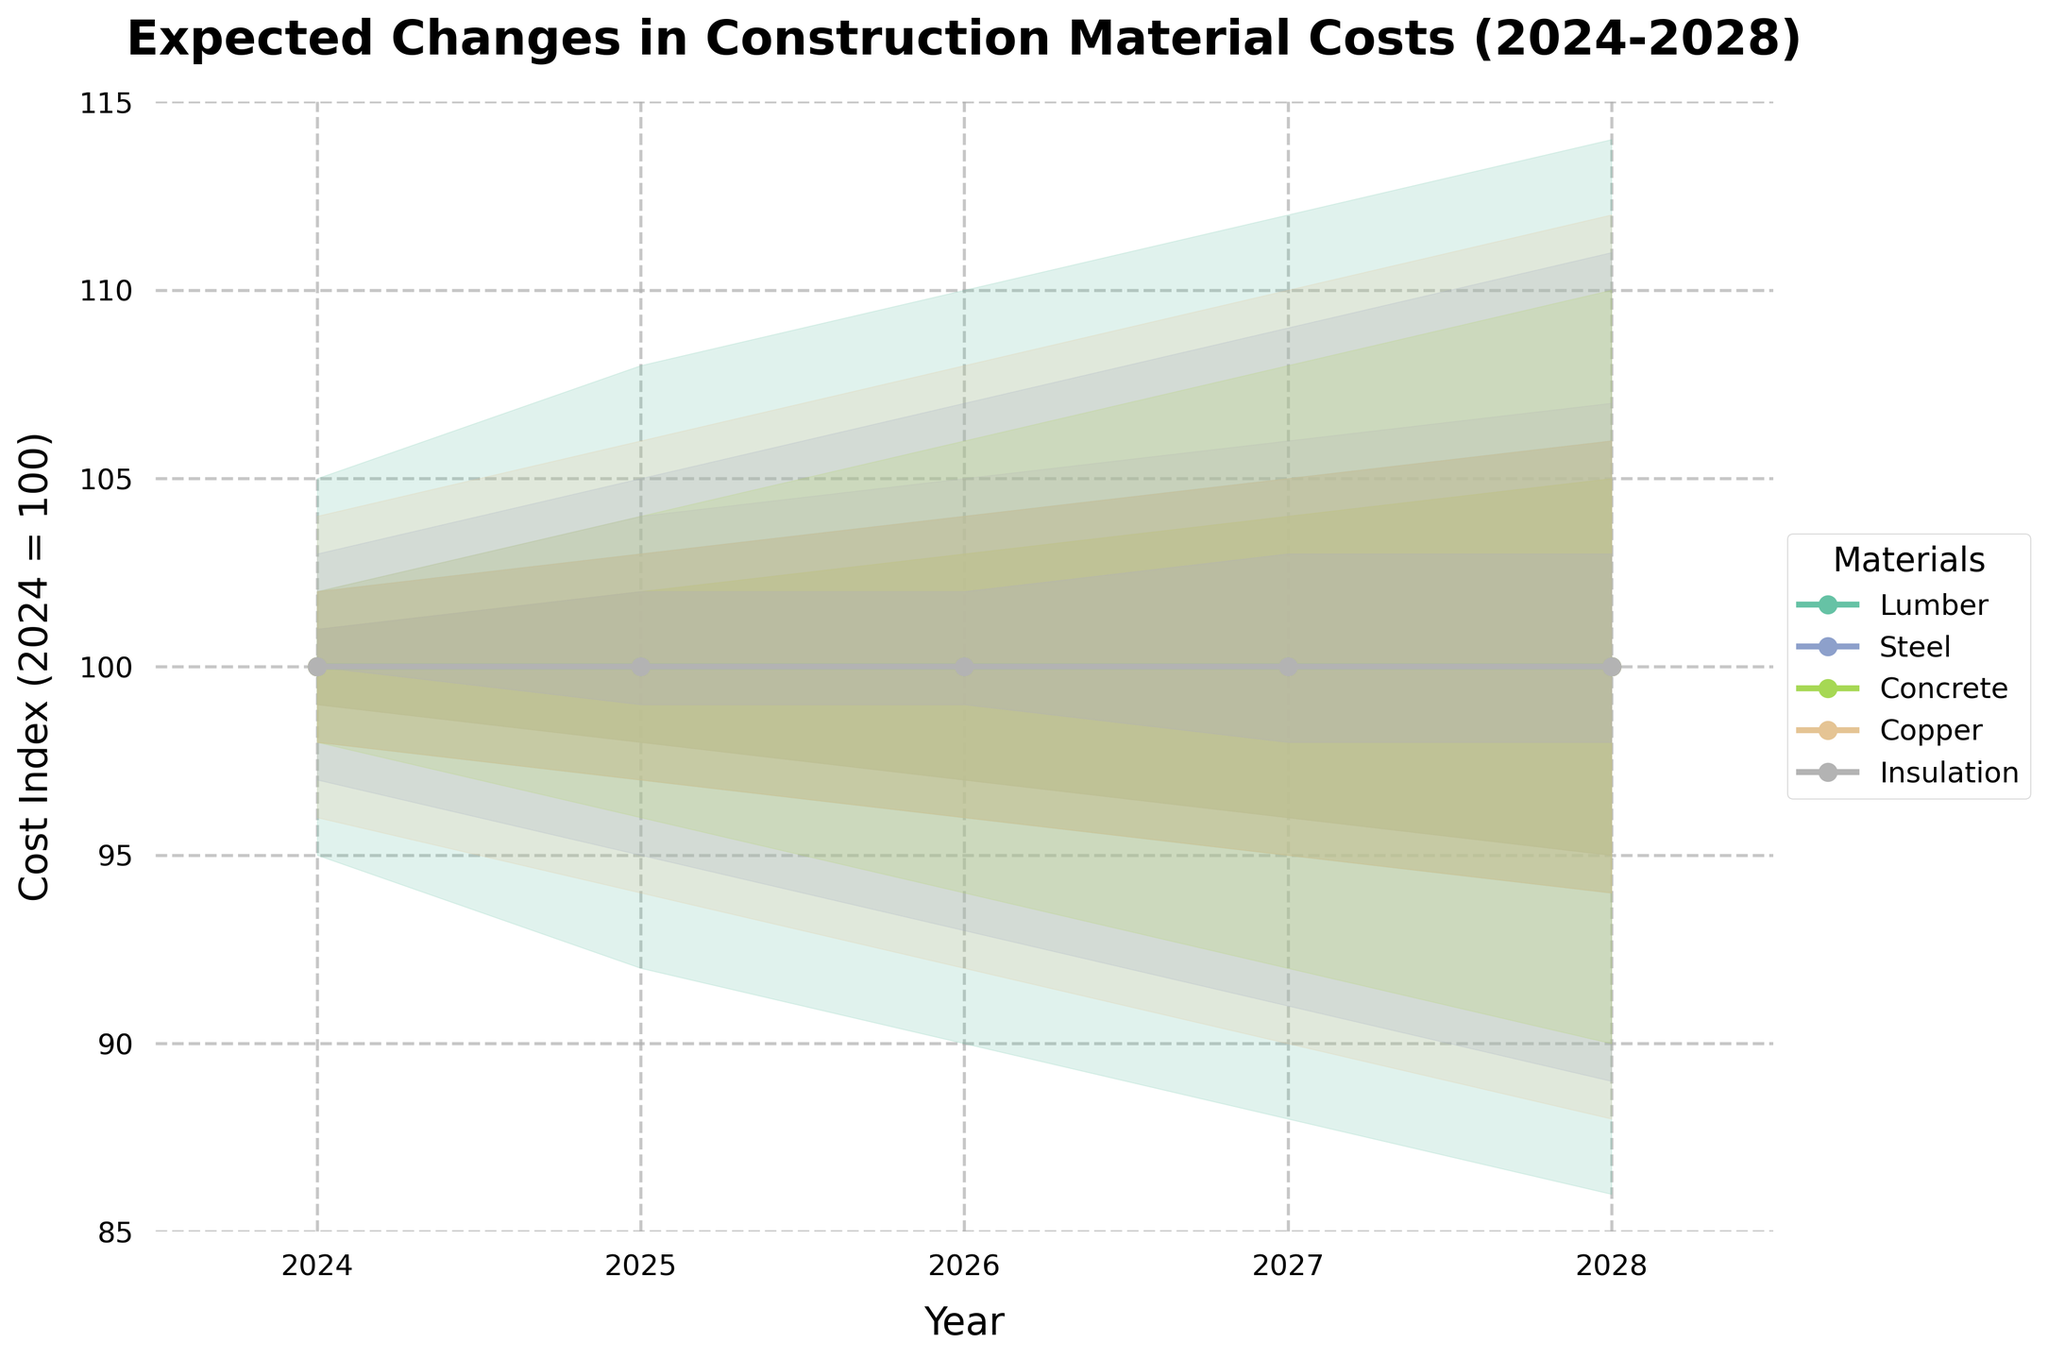What's the title of the chart? Look at the top of the chart where the title is usually placed. The title is "Expected Changes in Construction Material Costs (2024-2028)". This title describes what the chart is about.
Answer: Expected Changes in Construction Material Costs (2024-2028) What is the cost index range of Copper in 2026? Identify the representative shaded areas and the line plot for Copper in the year 2026. Copper in 2026 ranges from a Low of 92 to a High of 108.
Answer: 92 to 108 Which material has the highest expected cost in 2028? Compare the Mid (average) values for each material in 2028. The line for Lumber has the highest Mid value at 100, compared to others.
Answer: Lumber How does the cost index of Steel in 2025 compare to Concrete in the same year? Look at the 2025 data points for Steel and Concrete. Steel has Mid value of 100 and Concrete has Mid value of 100. So Steel's expected cost is equal to Concrete's in 2025.
Answer: Equal Which material shows the steepest increase in cost index from 2024 to 2028? Examine the slopes of the Mid value lines for each material from 2024 to 2028. Lumber shows the steepest increase, going from 100 to 100.
Answer: Lumber What is the range of predictions for the cost index of Insulation in 2027? Look at the shaded areas and lines for Insulation in 2027. The Low prediction is 96 and the High prediction is 106.
Answer: 96 to 106 What is the most likely value of Copper's cost index in 2028? Check the Mid value line for Copper in 2028. The Mid value for Copper in that year is 100.
Answer: 100 Among the materials, which one has the narrowest range of cost predictions in 2026? Compare the width of the shaded areas for all materials in 2026. Insulation has the narrowest range, with predictions from 97 to 105.
Answer: Insulation Which material has the most uncertain cost changes according to the 2027 predictions? Examine the range from Low to High for 2027. Lumber shows the widest range (88 to 112), indicating the most uncertainty.
Answer: Lumber What is the cost index prediction range for Concrete in 2025? Examine the shaded prediction areas for Concrete in 2025. The Low value is 96, while the High value is 104.
Answer: 96 to 104 